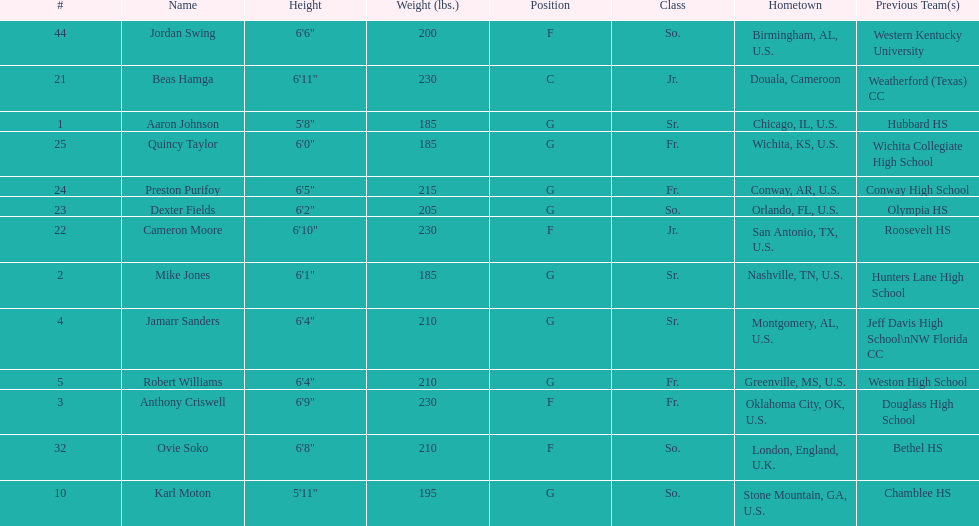Could you parse the entire table? {'header': ['#', 'Name', 'Height', 'Weight (lbs.)', 'Position', 'Class', 'Hometown', 'Previous Team(s)'], 'rows': [['44', 'Jordan Swing', '6\'6"', '200', 'F', 'So.', 'Birmingham, AL, U.S.', 'Western Kentucky University'], ['21', 'Beas Hamga', '6\'11"', '230', 'C', 'Jr.', 'Douala, Cameroon', 'Weatherford (Texas) CC'], ['1', 'Aaron Johnson', '5\'8"', '185', 'G', 'Sr.', 'Chicago, IL, U.S.', 'Hubbard HS'], ['25', 'Quincy Taylor', '6\'0"', '185', 'G', 'Fr.', 'Wichita, KS, U.S.', 'Wichita Collegiate High School'], ['24', 'Preston Purifoy', '6\'5"', '215', 'G', 'Fr.', 'Conway, AR, U.S.', 'Conway High School'], ['23', 'Dexter Fields', '6\'2"', '205', 'G', 'So.', 'Orlando, FL, U.S.', 'Olympia HS'], ['22', 'Cameron Moore', '6\'10"', '230', 'F', 'Jr.', 'San Antonio, TX, U.S.', 'Roosevelt HS'], ['2', 'Mike Jones', '6\'1"', '185', 'G', 'Sr.', 'Nashville, TN, U.S.', 'Hunters Lane High School'], ['4', 'Jamarr Sanders', '6\'4"', '210', 'G', 'Sr.', 'Montgomery, AL, U.S.', 'Jeff Davis High School\\nNW Florida CC'], ['5', 'Robert Williams', '6\'4"', '210', 'G', 'Fr.', 'Greenville, MS, U.S.', 'Weston High School'], ['3', 'Anthony Criswell', '6\'9"', '230', 'F', 'Fr.', 'Oklahoma City, OK, U.S.', 'Douglass High School'], ['32', 'Ovie Soko', '6\'8"', '210', 'F', 'So.', 'London, England, U.K.', 'Bethel HS'], ['10', 'Karl Moton', '5\'11"', '195', 'G', 'So.', 'Stone Mountain, GA, U.S.', 'Chamblee HS']]} What is the average weight of jamarr sanders and robert williams? 210. 